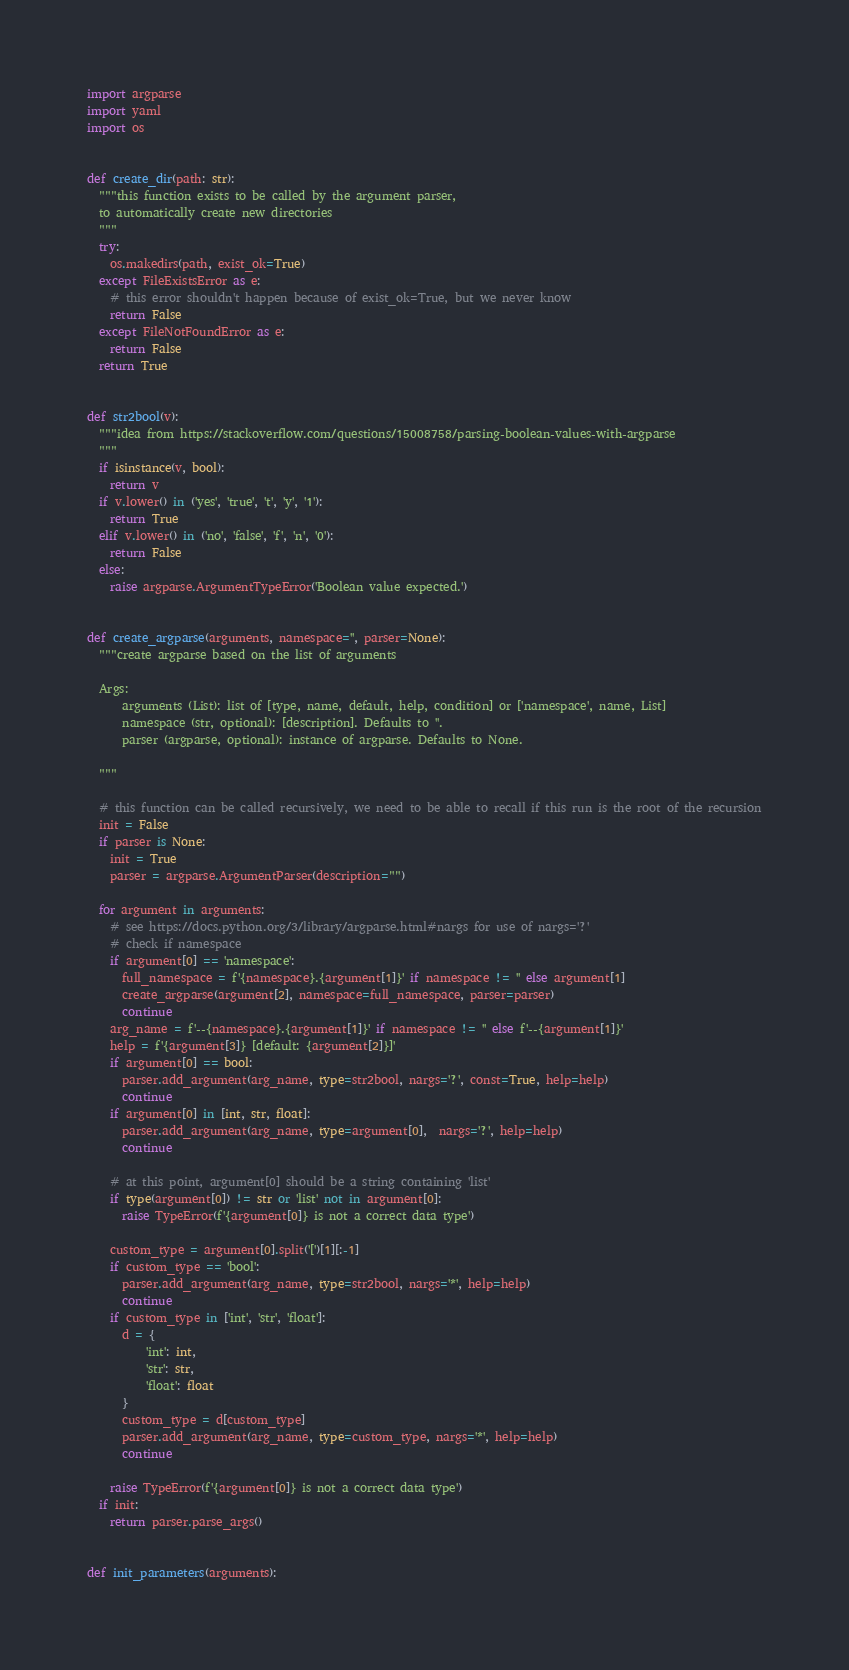Convert code to text. <code><loc_0><loc_0><loc_500><loc_500><_Python_>import argparse
import yaml
import os


def create_dir(path: str):
  """this function exists to be called by the argument parser, 
  to automatically create new directories
  """
  try:
    os.makedirs(path, exist_ok=True)
  except FileExistsError as e:
    # this error shouldn't happen because of exist_ok=True, but we never know
    return False
  except FileNotFoundError as e:
    return False
  return True


def str2bool(v):
  """idea from https://stackoverflow.com/questions/15008758/parsing-boolean-values-with-argparse
  """
  if isinstance(v, bool):
    return v
  if v.lower() in ('yes', 'true', 't', 'y', '1'):
    return True
  elif v.lower() in ('no', 'false', 'f', 'n', '0'):
    return False
  else:
    raise argparse.ArgumentTypeError('Boolean value expected.')


def create_argparse(arguments, namespace='', parser=None):
  """create argparse based on the list of arguments

  Args:
      arguments (List): list of [type, name, default, help, condition] or ['namespace', name, List]
      namespace (str, optional): [description]. Defaults to ''.
      parser (argparse, optional): instance of argparse. Defaults to None.

  """

  # this function can be called recursively, we need to be able to recall if this run is the root of the recursion
  init = False
  if parser is None:
    init = True
    parser = argparse.ArgumentParser(description="")

  for argument in arguments:
    # see https://docs.python.org/3/library/argparse.html#nargs for use of nargs='?'
    # check if namespace
    if argument[0] == 'namespace':
      full_namespace = f'{namespace}.{argument[1]}' if namespace != '' else argument[1]
      create_argparse(argument[2], namespace=full_namespace, parser=parser)
      continue
    arg_name = f'--{namespace}.{argument[1]}' if namespace != '' else f'--{argument[1]}'
    help = f'{argument[3]} [default: {argument[2]}]'
    if argument[0] == bool:
      parser.add_argument(arg_name, type=str2bool, nargs='?', const=True, help=help)
      continue
    if argument[0] in [int, str, float]:
      parser.add_argument(arg_name, type=argument[0],  nargs='?', help=help)
      continue

    # at this point, argument[0] should be a string containing 'list'
    if type(argument[0]) != str or 'list' not in argument[0]:
      raise TypeError(f'{argument[0]} is not a correct data type')

    custom_type = argument[0].split('[')[1][:-1]
    if custom_type == 'bool':
      parser.add_argument(arg_name, type=str2bool, nargs='*', help=help)
      continue
    if custom_type in ['int', 'str', 'float']:
      d = {
          'int': int,
          'str': str,
          'float': float
      }
      custom_type = d[custom_type]
      parser.add_argument(arg_name, type=custom_type, nargs='*', help=help)
      continue

    raise TypeError(f'{argument[0]} is not a correct data type')
  if init:
    return parser.parse_args()


def init_parameters(arguments):</code> 